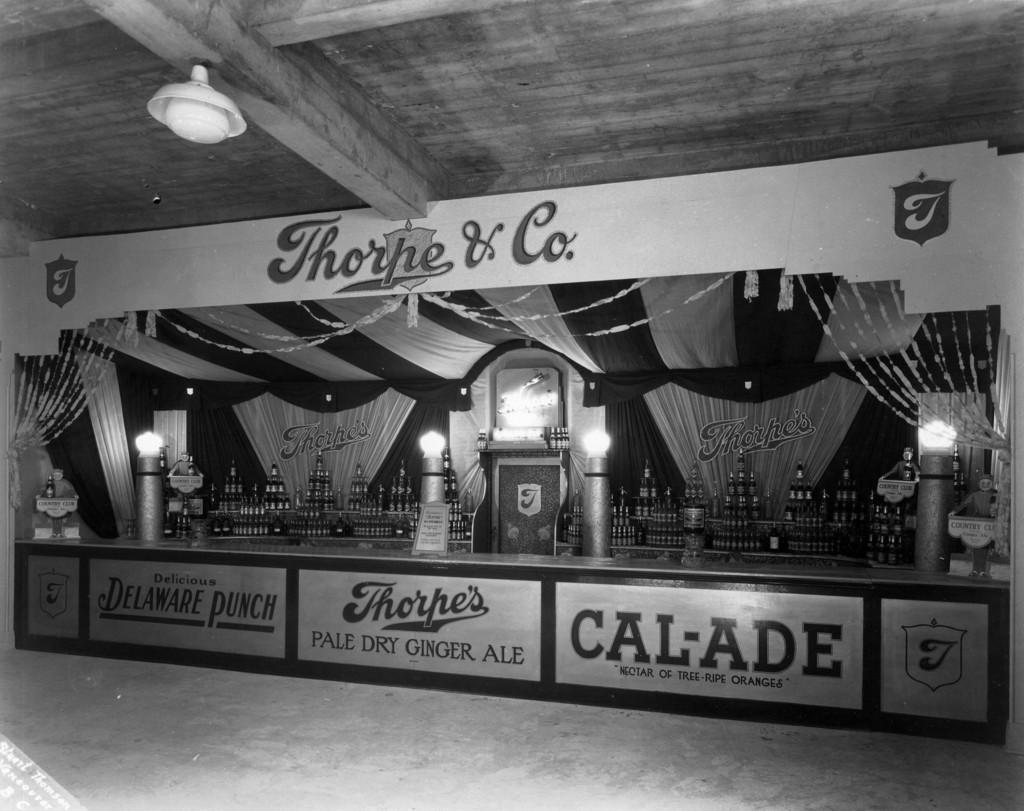Could you give a brief overview of what you see in this image? In this picture I can see the bottles on the desk. I can see boards. I can see light arrangement on the roof. 